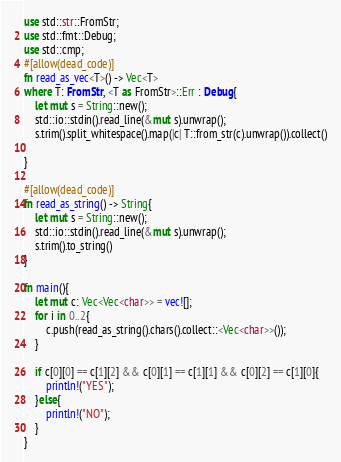Convert code to text. <code><loc_0><loc_0><loc_500><loc_500><_Rust_>use std::str::FromStr;
use std::fmt::Debug;
use std::cmp;
#[allow(dead_code)]
fn read_as_vec<T>() -> Vec<T>
where T: FromStr, <T as FromStr>::Err : Debug{
    let mut s = String::new();
    std::io::stdin().read_line(&mut s).unwrap();
    s.trim().split_whitespace().map(|c| T::from_str(c).unwrap()).collect()

}

#[allow(dead_code)]
fn read_as_string() -> String{
    let mut s = String::new();
    std::io::stdin().read_line(&mut s).unwrap();
    s.trim().to_string()
}

fn main(){
    let mut c: Vec<Vec<char>> = vec![];
    for i in 0..2{
        c.push(read_as_string().chars().collect::<Vec<char>>());
    }

    if c[0][0] == c[1][2] && c[0][1] == c[1][1] && c[0][2] == c[1][0]{
        println!("YES");
    }else{
        println!("NO");
    }
}
</code> 